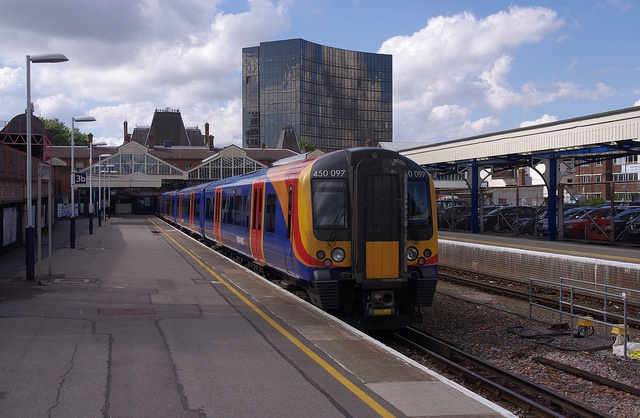Describe the objects in this image and their specific colors. I can see train in darkgray, black, navy, gray, and maroon tones, car in darkgray, black, gray, and darkblue tones, car in darkgray, black, purple, and maroon tones, car in darkgray, black, gray, and navy tones, and car in darkgray, black, gray, and darkblue tones in this image. 